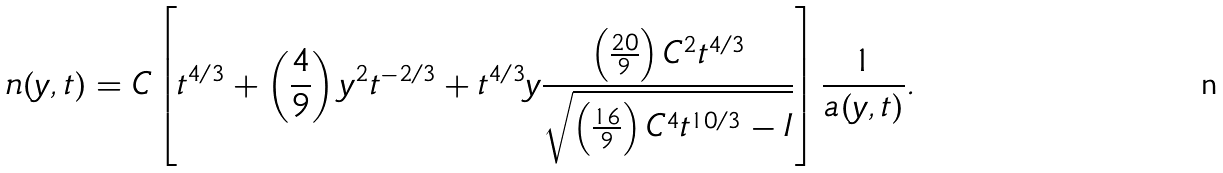Convert formula to latex. <formula><loc_0><loc_0><loc_500><loc_500>n ( y , t ) = C \left [ t ^ { 4 / 3 } + \left ( \frac { 4 } { 9 } \right ) y ^ { 2 } t ^ { - 2 / 3 } + t ^ { 4 / 3 } y \frac { \left ( \frac { 2 0 } { 9 } \right ) C ^ { 2 } t ^ { 4 / 3 } } { \sqrt { \left ( \frac { 1 6 } { 9 } \right ) C ^ { 4 } t ^ { 1 0 / 3 } - I } } \right ] \frac { 1 } { a ( y , t ) } .</formula> 